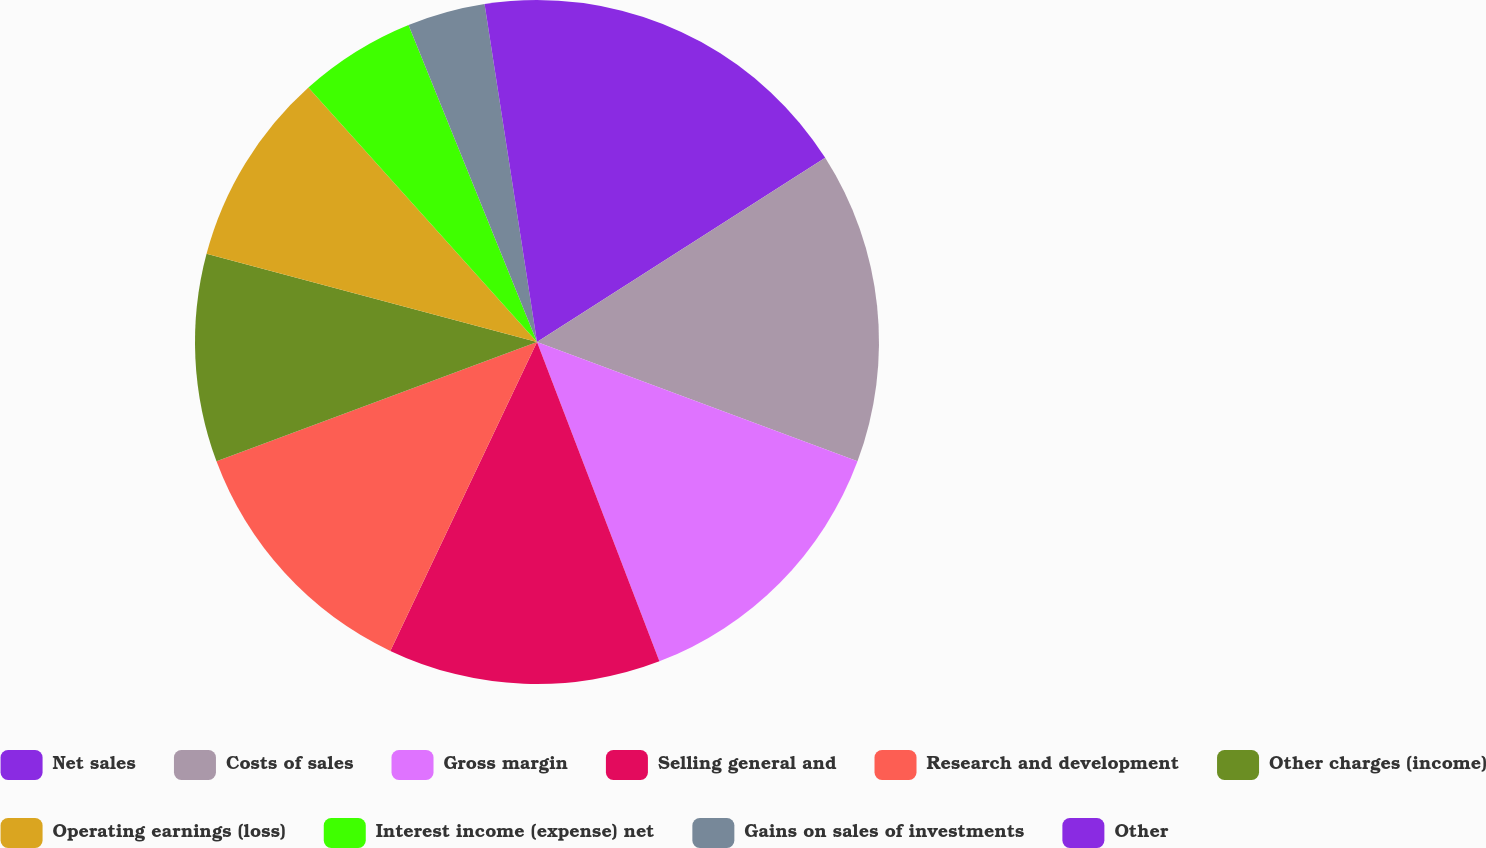<chart> <loc_0><loc_0><loc_500><loc_500><pie_chart><fcel>Net sales<fcel>Costs of sales<fcel>Gross margin<fcel>Selling general and<fcel>Research and development<fcel>Other charges (income)<fcel>Operating earnings (loss)<fcel>Interest income (expense) net<fcel>Gains on sales of investments<fcel>Other<nl><fcel>15.95%<fcel>14.72%<fcel>13.5%<fcel>12.88%<fcel>12.27%<fcel>9.82%<fcel>9.2%<fcel>5.52%<fcel>3.68%<fcel>2.45%<nl></chart> 